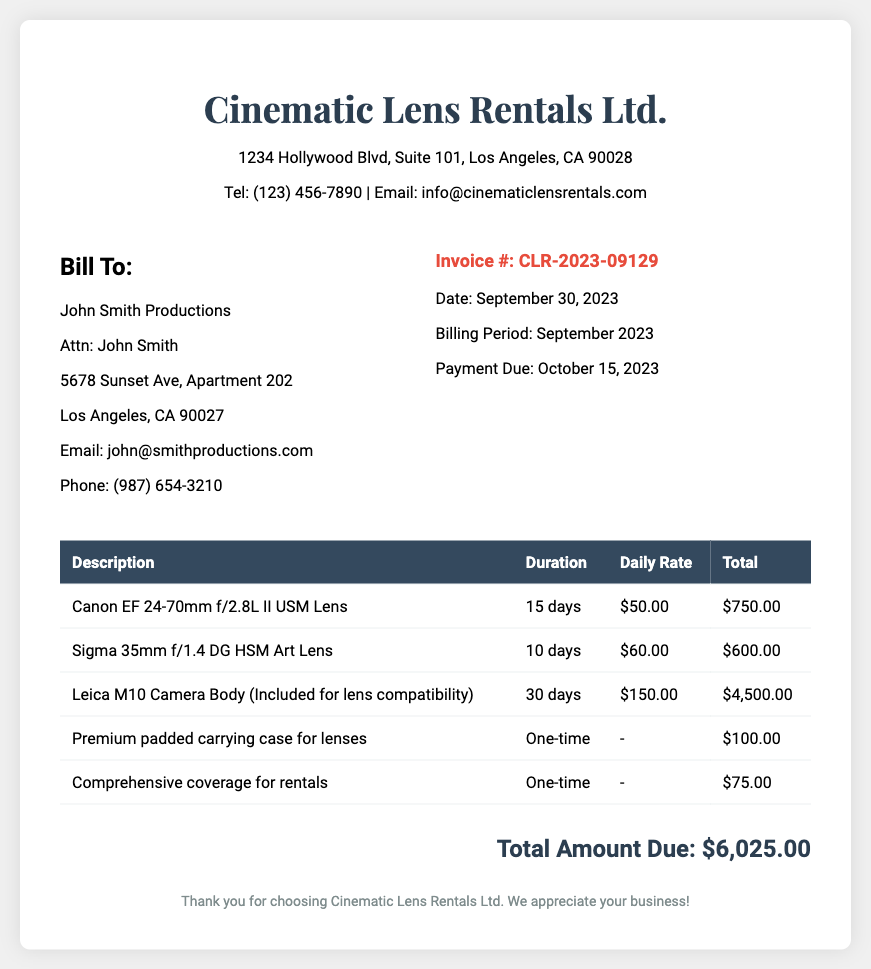What is the company name? The company name is displayed prominently at the top of the document.
Answer: Cinematic Lens Rentals Ltd What is the invoice number? The invoice number can be found under the billing details section.
Answer: CLR-2023-09129 What is the total amount due? The total amount due is summarized at the bottom of the invoice.
Answer: $6,025.00 How many days was the Sigma 35mm lens rented? The rental duration for the Sigma 35mm lens is listed in the itemized charges.
Answer: 10 days What is included for lens compatibility? The document specifies an inclusion relevant to the lenses rented.
Answer: Leica M10 Camera Body How much is the daily rate for the Canon EF lens? The daily rate for the Canon EF lens is detailed in the table of itemized charges.
Answer: $50.00 When is the payment due? The payment due date is mentioned in the billing details section.
Answer: October 15, 2023 What is the billing period for this invoice? The billing period can be found within the invoice details.
Answer: September 2023 What type of coverage is included for rentals? The type of coverage is specified in the itemized charges.
Answer: Comprehensive coverage 